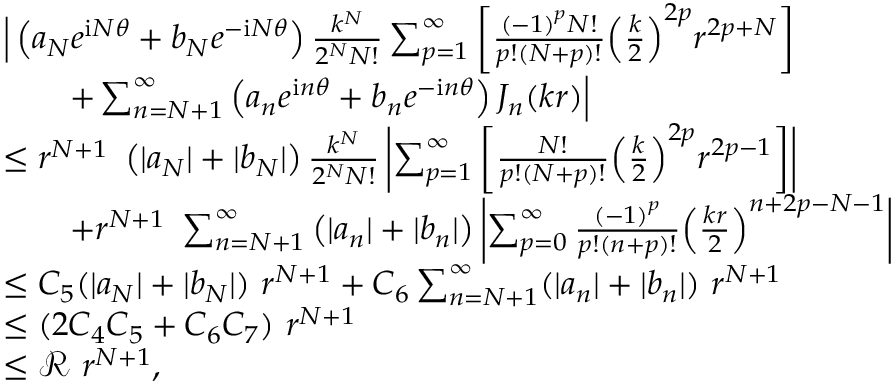Convert formula to latex. <formula><loc_0><loc_0><loc_500><loc_500>\begin{array} { r l } & { \left | \left ( { a _ { N } } { e ^ { \mathrm i N \theta } } + { b _ { N } } { e ^ { - \mathrm i N \theta } } \right ) { \frac { { k ^ { N } } } { { 2 ^ { N } } N ! } } \sum _ { p = 1 } ^ { \infty } { \left [ { { \frac { { { ( - 1 ) } ^ { p } } N ! } { p ! ( N + p ) ! } } { { \left ( { { \frac { k } { 2 } } } \right ) } ^ { 2 p } } { r ^ { 2 p + N } } } \right ] } } \\ & { \quad + \sum _ { n = N + 1 } ^ { \infty } { \left ( { a _ { n } } { e ^ { \mathrm i n \theta } } + { b _ { n } } { e ^ { - \mathrm i n \theta } } \right ) { J _ { n } } ( k r ) } \right | } \\ & { \leq r ^ { N + 1 } \ \left ( | { a _ { N } } | + | { b _ { N } } | \right ) { \frac { { k ^ { N } } } { { 2 ^ { N } } N ! } } \left | \sum _ { p = 1 } ^ { \infty } { \left [ { { \frac { N ! } { p ! ( N + p ) ! } } { { \left ( { { \frac { k } { 2 } } } \right ) } ^ { 2 p } } { r ^ { 2 p - 1 } } } \right ] } \right | } \\ & { \quad + r ^ { N + 1 } \ \sum _ { n = N + 1 } ^ { \infty } { \left ( | { a _ { n } } | + | { b _ { n } } | \right ) } \left | \sum _ { p = 0 } ^ { \infty } { { \frac { { { ( - 1 ) } ^ { p } } } { p ! ( n + p ) ! } } { { \left ( { { \frac { k r } { 2 } } } \right ) } ^ { n + 2 p - N - 1 } } } \right | } \\ & { \leq C _ { 5 } ( | a _ { N } | + | b _ { N } | ) \ r ^ { N + 1 } + C _ { 6 } \sum _ { n = N + 1 } ^ { \infty } ( | a _ { n } | + | b _ { n } | ) \ r ^ { N + 1 } } \\ & { \leq ( 2 C _ { 4 } C _ { 5 } + C _ { 6 } C _ { 7 } ) \ r ^ { N + 1 } } \\ & { \leq \mathcal { R } \ r ^ { N + 1 } , } \end{array}</formula> 